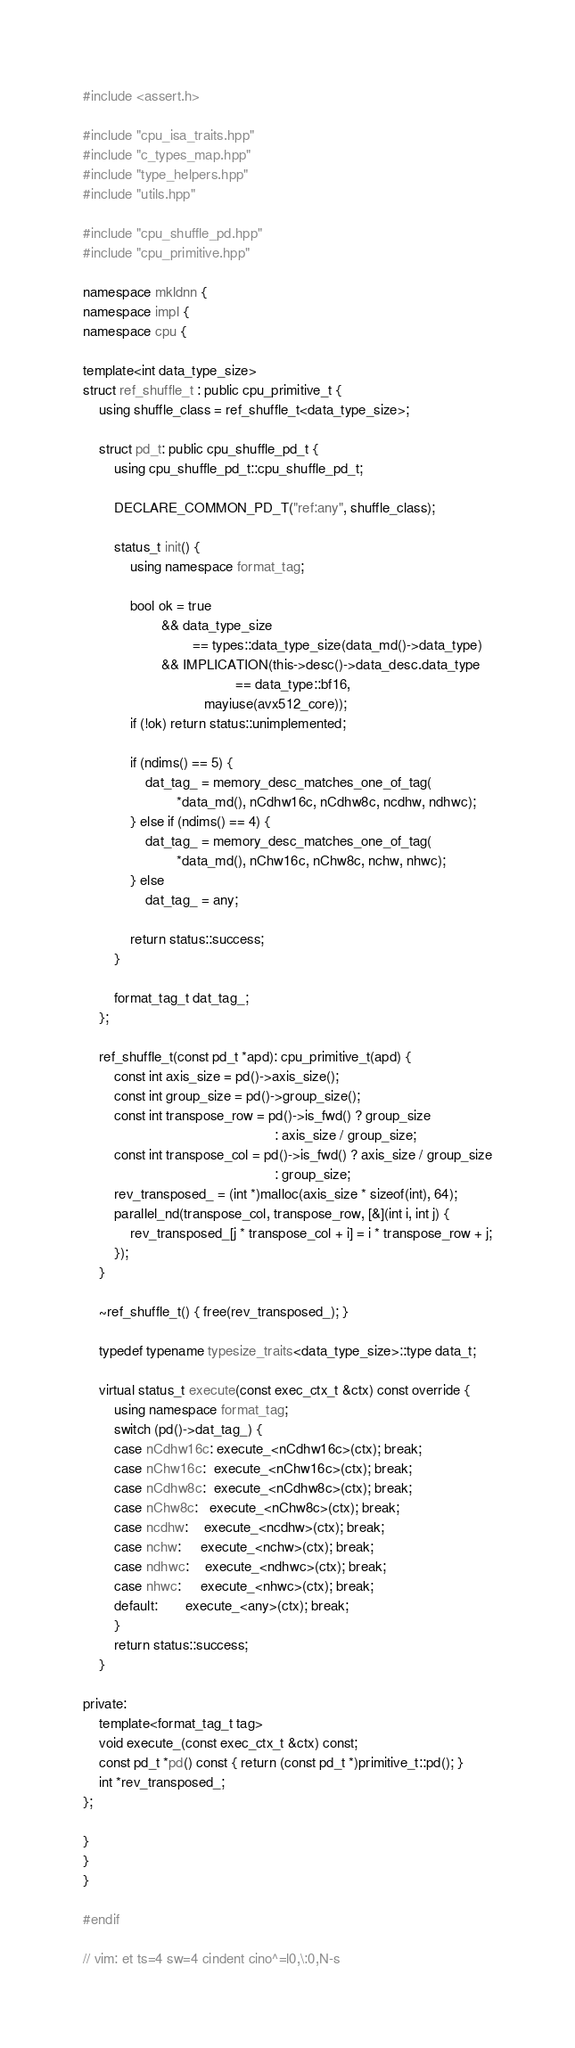Convert code to text. <code><loc_0><loc_0><loc_500><loc_500><_C++_>#include <assert.h>

#include "cpu_isa_traits.hpp"
#include "c_types_map.hpp"
#include "type_helpers.hpp"
#include "utils.hpp"

#include "cpu_shuffle_pd.hpp"
#include "cpu_primitive.hpp"

namespace mkldnn {
namespace impl {
namespace cpu {

template<int data_type_size>
struct ref_shuffle_t : public cpu_primitive_t {
    using shuffle_class = ref_shuffle_t<data_type_size>;

    struct pd_t: public cpu_shuffle_pd_t {
        using cpu_shuffle_pd_t::cpu_shuffle_pd_t;

        DECLARE_COMMON_PD_T("ref:any", shuffle_class);

        status_t init() {
            using namespace format_tag;

            bool ok = true
                    && data_type_size
                            == types::data_type_size(data_md()->data_type)
                    && IMPLICATION(this->desc()->data_desc.data_type
                                       == data_type::bf16,
                               mayiuse(avx512_core));
            if (!ok) return status::unimplemented;

            if (ndims() == 5) {
                dat_tag_ = memory_desc_matches_one_of_tag(
                        *data_md(), nCdhw16c, nCdhw8c, ncdhw, ndhwc);
            } else if (ndims() == 4) {
                dat_tag_ = memory_desc_matches_one_of_tag(
                        *data_md(), nChw16c, nChw8c, nchw, nhwc);
            } else
                dat_tag_ = any;

            return status::success;
        }

        format_tag_t dat_tag_;
    };

    ref_shuffle_t(const pd_t *apd): cpu_primitive_t(apd) {
        const int axis_size = pd()->axis_size();
        const int group_size = pd()->group_size();
        const int transpose_row = pd()->is_fwd() ? group_size
                                                 : axis_size / group_size;
        const int transpose_col = pd()->is_fwd() ? axis_size / group_size
                                                 : group_size;
        rev_transposed_ = (int *)malloc(axis_size * sizeof(int), 64);
        parallel_nd(transpose_col, transpose_row, [&](int i, int j) {
            rev_transposed_[j * transpose_col + i] = i * transpose_row + j;
        });
    }

    ~ref_shuffle_t() { free(rev_transposed_); }

    typedef typename typesize_traits<data_type_size>::type data_t;

    virtual status_t execute(const exec_ctx_t &ctx) const override {
        using namespace format_tag;
        switch (pd()->dat_tag_) {
        case nCdhw16c: execute_<nCdhw16c>(ctx); break;
        case nChw16c:  execute_<nChw16c>(ctx); break;
        case nCdhw8c:  execute_<nCdhw8c>(ctx); break;
        case nChw8c:   execute_<nChw8c>(ctx); break;
        case ncdhw:    execute_<ncdhw>(ctx); break;
        case nchw:     execute_<nchw>(ctx); break;
        case ndhwc:    execute_<ndhwc>(ctx); break;
        case nhwc:     execute_<nhwc>(ctx); break;
        default:       execute_<any>(ctx); break;
        }
        return status::success;
    }

private:
    template<format_tag_t tag>
    void execute_(const exec_ctx_t &ctx) const;
    const pd_t *pd() const { return (const pd_t *)primitive_t::pd(); }
    int *rev_transposed_;
};

}
}
}

#endif

// vim: et ts=4 sw=4 cindent cino^=l0,\:0,N-s
</code> 